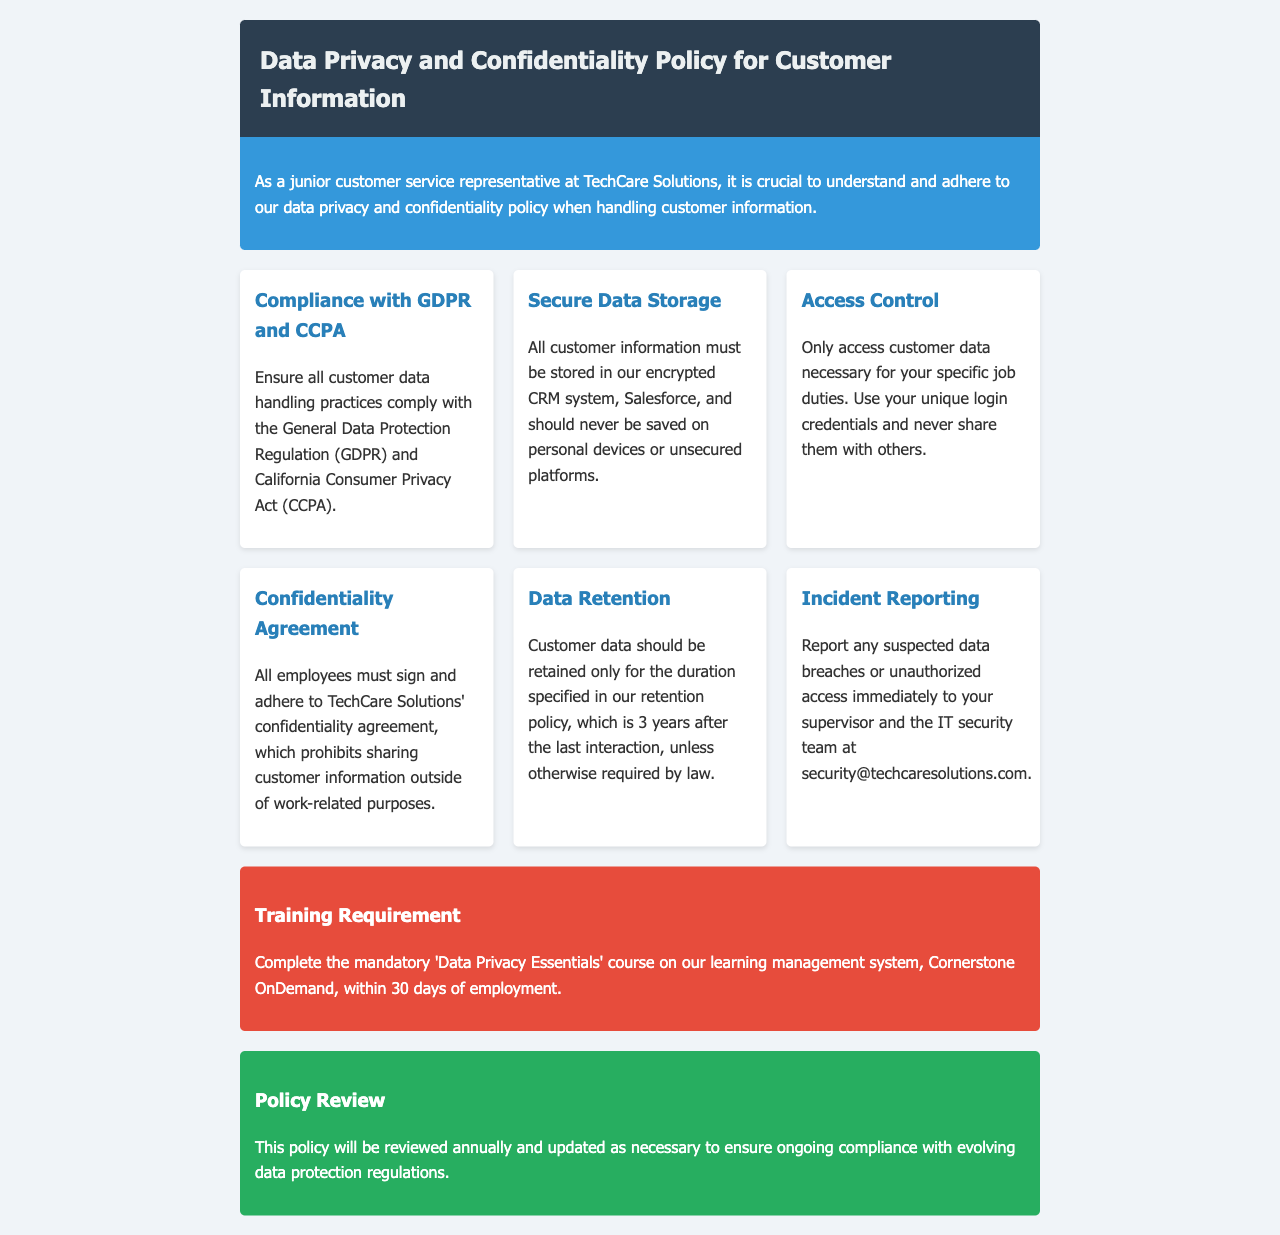What regulation must customer data handling practices comply with? The document specifies that all customer data handling practices must comply with the General Data Protection Regulation (GDPR).
Answer: GDPR What is the data retention period specified in the policy? The document mentions that customer data should be retained for 3 years after the last interaction.
Answer: 3 years Who should be reported to in case of a suspected data breach? According to the policy, any suspected data breaches should be reported to your supervisor and the IT security team.
Answer: Supervisor and IT security team What course must new employees complete within 30 days? The policy requires new employees to complete the 'Data Privacy Essentials' course within 30 days of employment.
Answer: 'Data Privacy Essentials' What should customer information never be saved on? The policy states that customer information should never be saved on personal devices or unsecured platforms.
Answer: Personal devices or unsecured platforms Why must employees sign a confidentiality agreement? The confidentiality agreement is necessary to prohibit sharing customer information outside of work-related purposes.
Answer: To prohibit sharing customer information How often will this policy be reviewed? The document states that the policy will be reviewed annually.
Answer: Annually What system is used for secure data storage? The document specifies that all customer information must be stored in the encrypted CRM system, Salesforce.
Answer: Salesforce 